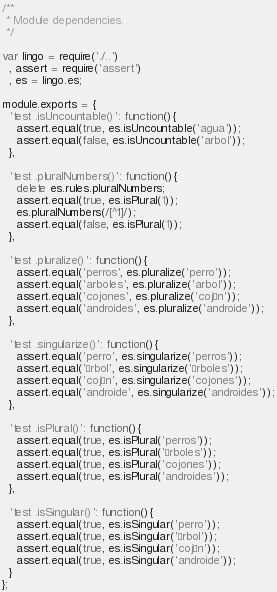Convert code to text. <code><loc_0><loc_0><loc_500><loc_500><_JavaScript_>/**
 * Module dependencies.
 */

var lingo = require('./..')
  , assert = require('assert')
  , es = lingo.es;

module.exports = {
  'test .isUncountable()': function(){
    assert.equal(true, es.isUncountable('agua'));
    assert.equal(false, es.isUncountable('arbol'));
  },

  'test .pluralNumbers()': function(){
    delete es.rules.pluralNumbers;
    assert.equal(true, es.isPlural(1));
    es.pluralNumbers(/[^1]/);
    assert.equal(false, es.isPlural(1));
  },

  'test .pluralize()': function(){
    assert.equal('perros', es.pluralize('perro'));
    assert.equal('arboles', es.pluralize('arbol'));
    assert.equal('cojones', es.pluralize('cojón'));
    assert.equal('androides', es.pluralize('androide'));
  },

  'test .singularize()': function(){
    assert.equal('perro', es.singularize('perros'));
    assert.equal('árbol', es.singularize('árboles'));
    assert.equal('cojón', es.singularize('cojones'));
    assert.equal('androide', es.singularize('androides'));
  },

  'test .isPlural()': function(){
    assert.equal(true, es.isPlural('perros'));
    assert.equal(true, es.isPlural('árboles'));
    assert.equal(true, es.isPlural('cojones'));
    assert.equal(true, es.isPlural('androides'));
  },

  'test .isSingular()': function(){
    assert.equal(true, es.isSingular('perro'));
    assert.equal(true, es.isSingular('árbol'));
    assert.equal(true, es.isSingular('cojón'));
    assert.equal(true, es.isSingular('androide'));
  }
};

</code> 